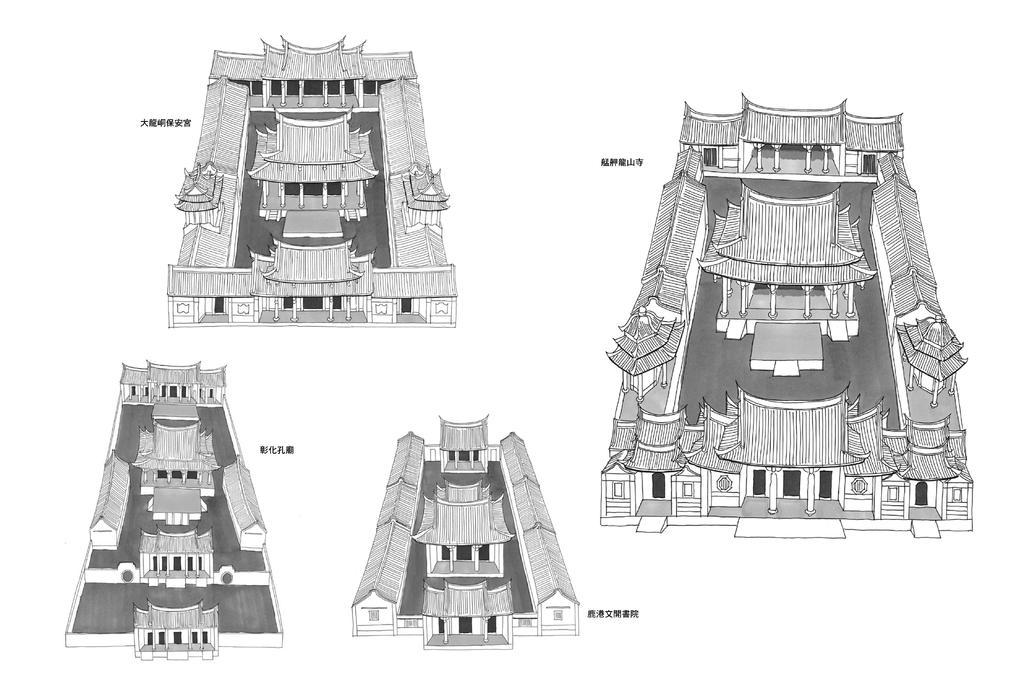What type of document is shown in the image? There are blueprints of a building in the image. What is located beside the blueprints? There is text beside the blueprints. How many basketballs can be seen in the image? There are no basketballs present in the image. Is there a goose visible in the image? There is no goose present in the image. 